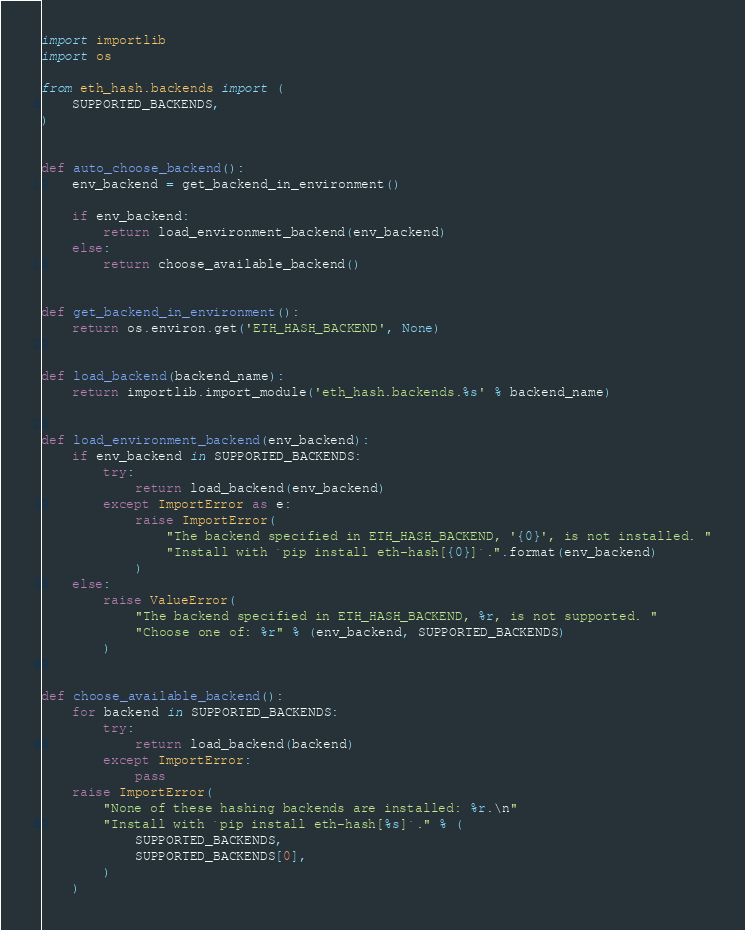<code> <loc_0><loc_0><loc_500><loc_500><_Python_>import importlib
import os

from eth_hash.backends import (
    SUPPORTED_BACKENDS,
)


def auto_choose_backend():
    env_backend = get_backend_in_environment()

    if env_backend:
        return load_environment_backend(env_backend)
    else:
        return choose_available_backend()


def get_backend_in_environment():
    return os.environ.get('ETH_HASH_BACKEND', None)


def load_backend(backend_name):
    return importlib.import_module('eth_hash.backends.%s' % backend_name)


def load_environment_backend(env_backend):
    if env_backend in SUPPORTED_BACKENDS:
        try:
            return load_backend(env_backend)
        except ImportError as e:
            raise ImportError(
                "The backend specified in ETH_HASH_BACKEND, '{0}', is not installed. "
                "Install with `pip install eth-hash[{0}]`.".format(env_backend)
            )
    else:
        raise ValueError(
            "The backend specified in ETH_HASH_BACKEND, %r, is not supported. "
            "Choose one of: %r" % (env_backend, SUPPORTED_BACKENDS)
        )


def choose_available_backend():
    for backend in SUPPORTED_BACKENDS:
        try:
            return load_backend(backend)
        except ImportError:
            pass
    raise ImportError(
        "None of these hashing backends are installed: %r.\n"
        "Install with `pip install eth-hash[%s]`." % (
            SUPPORTED_BACKENDS,
            SUPPORTED_BACKENDS[0],
        )
    )
</code> 